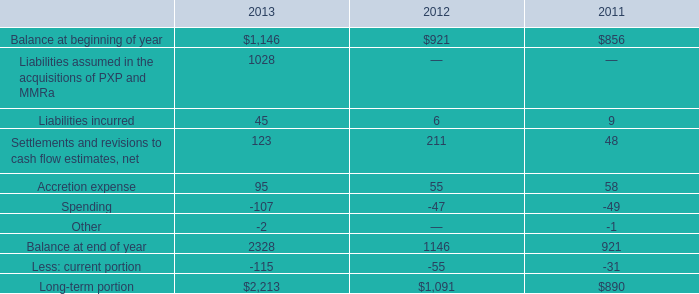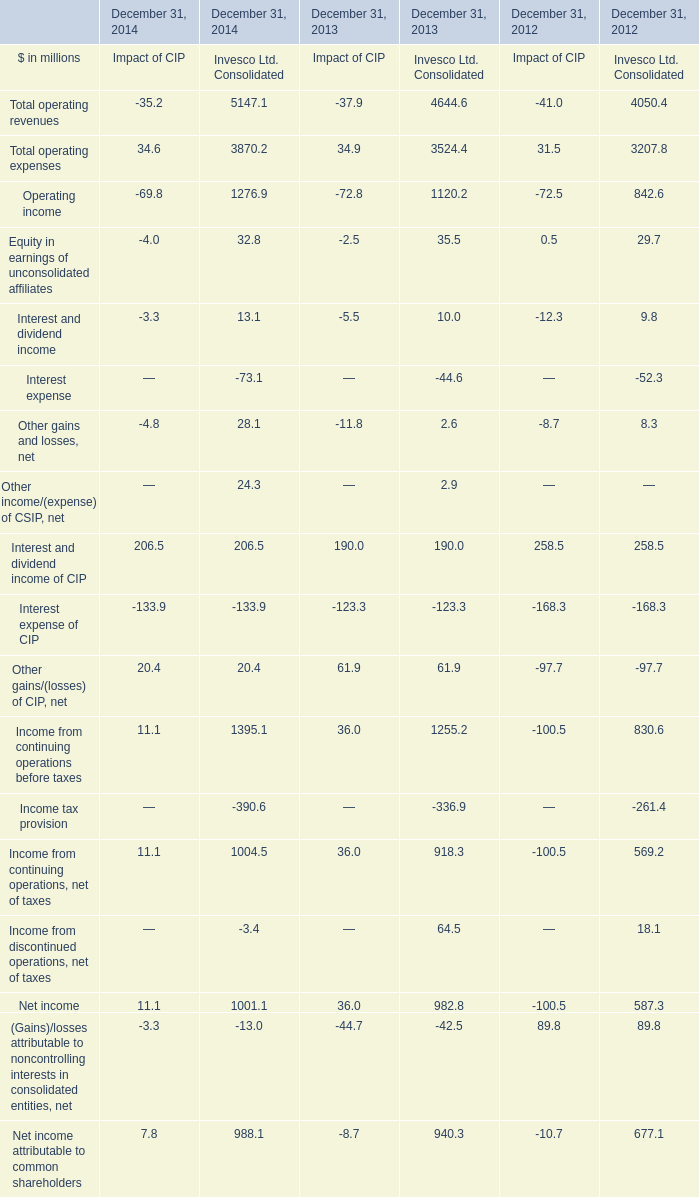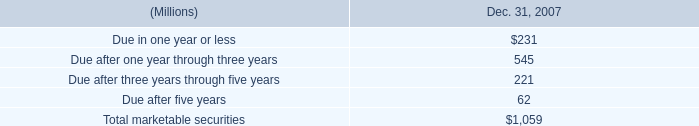What is the average value of Net income attributable to common shareholders at December 31, 2014,December 31, 2013 and December 31, 2012,in terms of Invesco Ltd. Consolidated? (in million) 
Computations: (((988.1 + 940.3) + 677.1) / 3)
Answer: 868.5. 